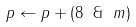Convert formula to latex. <formula><loc_0><loc_0><loc_500><loc_500>p \gets p + ( 8 \ \& \ m )</formula> 